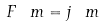<formula> <loc_0><loc_0><loc_500><loc_500>F ^ { \ } m = j ^ { \ } m</formula> 